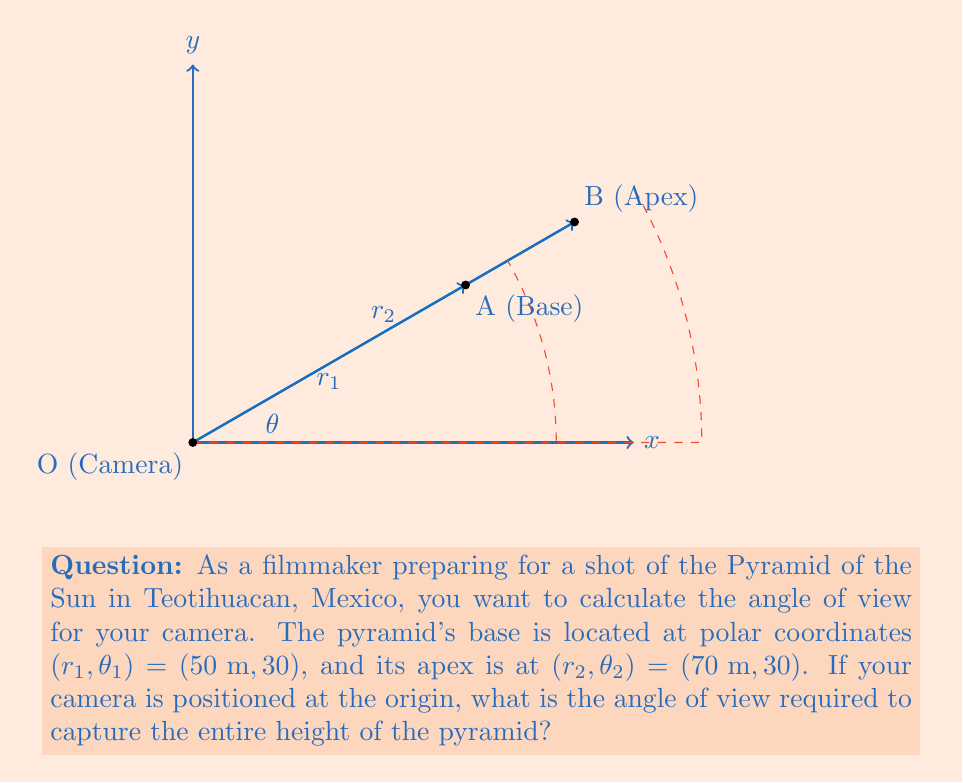Help me with this question. Let's approach this step-by-step:

1) In polar coordinates, the angle of view is the difference between the angles formed by the two radial lines from the origin to the points of interest.

2) However, in this case, both points lie on the same radial line ($\theta_1 = \theta_2 = 30°$), so we need to use the arctangent function to find the angle.

3) We can calculate the angle using the formula:

   $$\theta = \arctan\left(\frac{r_2 \sin(\theta_2) - r_1 \sin(\theta_1)}{r_2 \cos(\theta_2) - r_1 \cos(\theta_1)}\right)$$

4) Substituting the given values:

   $$\theta = \arctan\left(\frac{70 \sin(30°) - 50 \sin(30°)}{70 \cos(30°) - 50 \cos(30°)}\right)$$

5) Simplify:

   $$\theta = \arctan\left(\frac{20 \sin(30°)}{20 \cos(30°)}\right)$$

6) The $\sin(30°)$ and $\cos(30°)$ cancel out:

   $$\theta = \arctan\left(\frac{\sin(30°)}{\cos(30°)}\right)$$

7) This is equivalent to:

   $$\theta = \arctan(\tan(30°))$$

8) The arctangent and tangent functions cancel out:

   $$\theta = 30°$$

Therefore, the angle of view required to capture the entire height of the pyramid is 30°.
Answer: $30°$ 